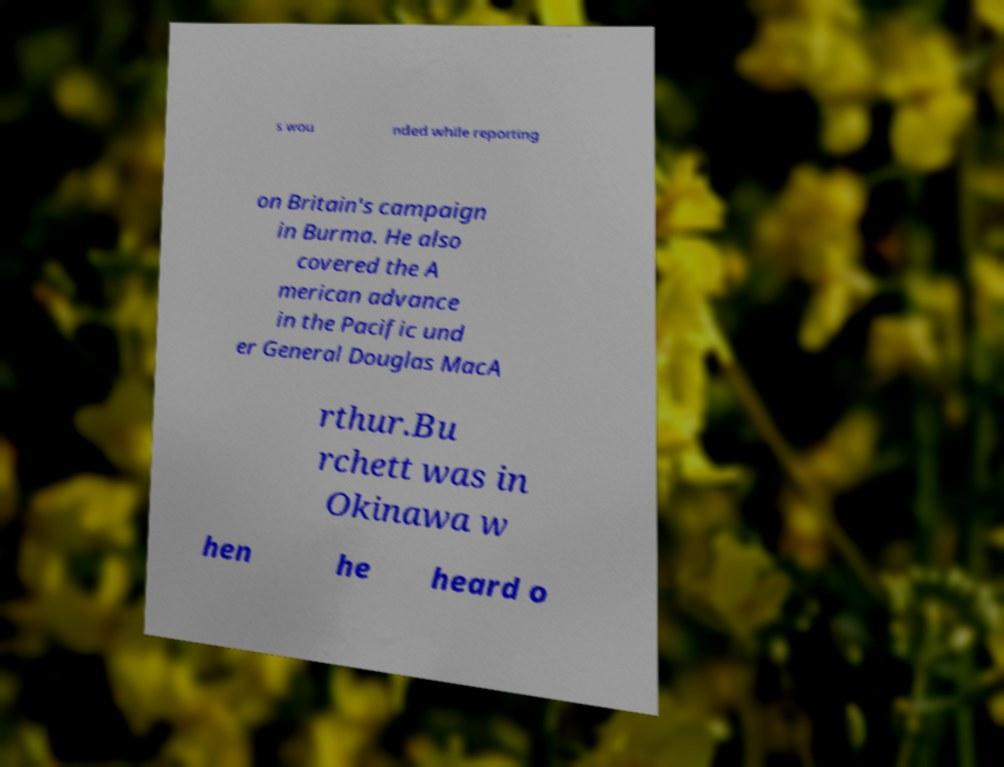Could you extract and type out the text from this image? s wou nded while reporting on Britain's campaign in Burma. He also covered the A merican advance in the Pacific und er General Douglas MacA rthur.Bu rchett was in Okinawa w hen he heard o 